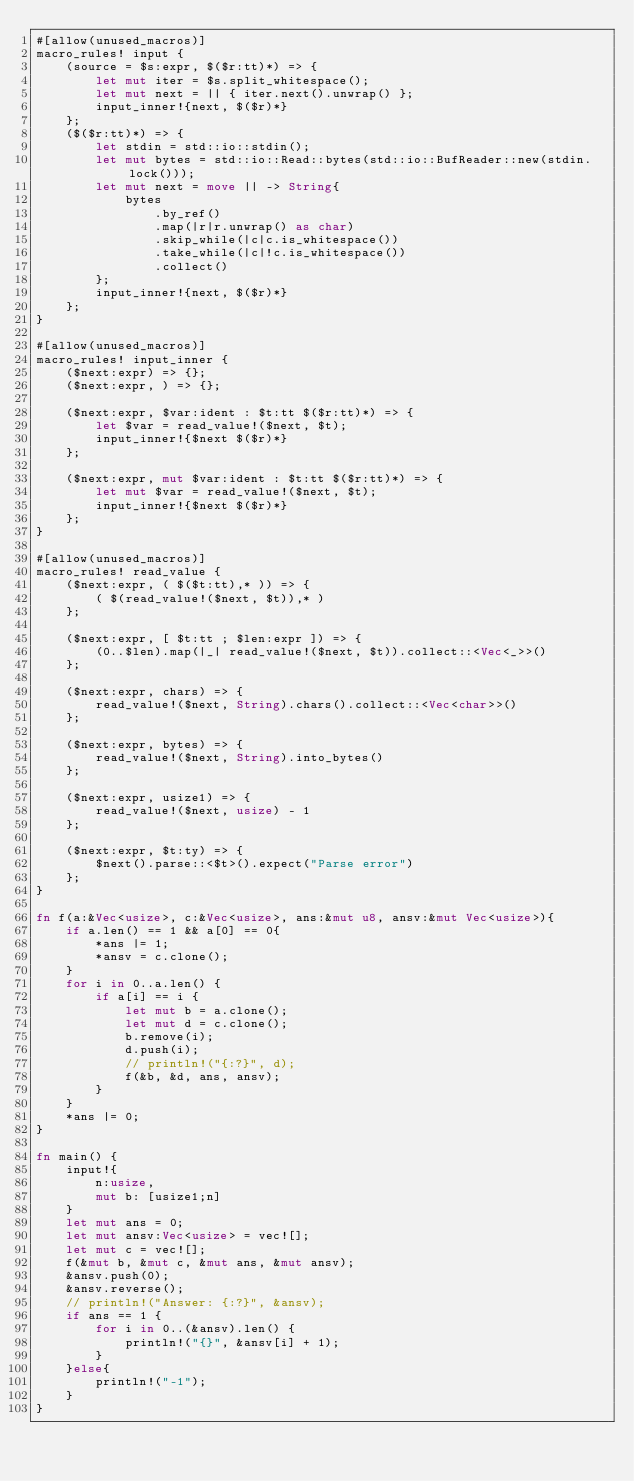<code> <loc_0><loc_0><loc_500><loc_500><_Rust_>#[allow(unused_macros)]
macro_rules! input {
    (source = $s:expr, $($r:tt)*) => {
        let mut iter = $s.split_whitespace();
        let mut next = || { iter.next().unwrap() };
        input_inner!{next, $($r)*}
    };
    ($($r:tt)*) => {
        let stdin = std::io::stdin();
        let mut bytes = std::io::Read::bytes(std::io::BufReader::new(stdin.lock()));
        let mut next = move || -> String{
            bytes
                .by_ref()
                .map(|r|r.unwrap() as char)
                .skip_while(|c|c.is_whitespace())
                .take_while(|c|!c.is_whitespace())
                .collect()
        };
        input_inner!{next, $($r)*}
    };
}

#[allow(unused_macros)]
macro_rules! input_inner {
    ($next:expr) => {};
    ($next:expr, ) => {};

    ($next:expr, $var:ident : $t:tt $($r:tt)*) => {
        let $var = read_value!($next, $t);
        input_inner!{$next $($r)*}
    };

    ($next:expr, mut $var:ident : $t:tt $($r:tt)*) => {
        let mut $var = read_value!($next, $t);
        input_inner!{$next $($r)*}
    };
}

#[allow(unused_macros)]
macro_rules! read_value {
    ($next:expr, ( $($t:tt),* )) => {
        ( $(read_value!($next, $t)),* )
    };

    ($next:expr, [ $t:tt ; $len:expr ]) => {
        (0..$len).map(|_| read_value!($next, $t)).collect::<Vec<_>>()
    };

    ($next:expr, chars) => {
        read_value!($next, String).chars().collect::<Vec<char>>()
    };

    ($next:expr, bytes) => {
        read_value!($next, String).into_bytes()
    };

    ($next:expr, usize1) => {
        read_value!($next, usize) - 1
    };

    ($next:expr, $t:ty) => {
        $next().parse::<$t>().expect("Parse error")
    };
}

fn f(a:&Vec<usize>, c:&Vec<usize>, ans:&mut u8, ansv:&mut Vec<usize>){
    if a.len() == 1 && a[0] == 0{
        *ans |= 1;
        *ansv = c.clone();
    }
    for i in 0..a.len() {
        if a[i] == i {
            let mut b = a.clone();
            let mut d = c.clone();
            b.remove(i);
            d.push(i);
            // println!("{:?}", d);
            f(&b, &d, ans, ansv);
        }
    }
    *ans |= 0;
}

fn main() {
    input!{
        n:usize,
        mut b: [usize1;n]
    }
    let mut ans = 0;
    let mut ansv:Vec<usize> = vec![];
    let mut c = vec![];
    f(&mut b, &mut c, &mut ans, &mut ansv);
    &ansv.push(0);
    &ansv.reverse();
    // println!("Answer: {:?}", &ansv);
    if ans == 1 {
        for i in 0..(&ansv).len() {
            println!("{}", &ansv[i] + 1);
        }
    }else{
        println!("-1");
    }
}</code> 